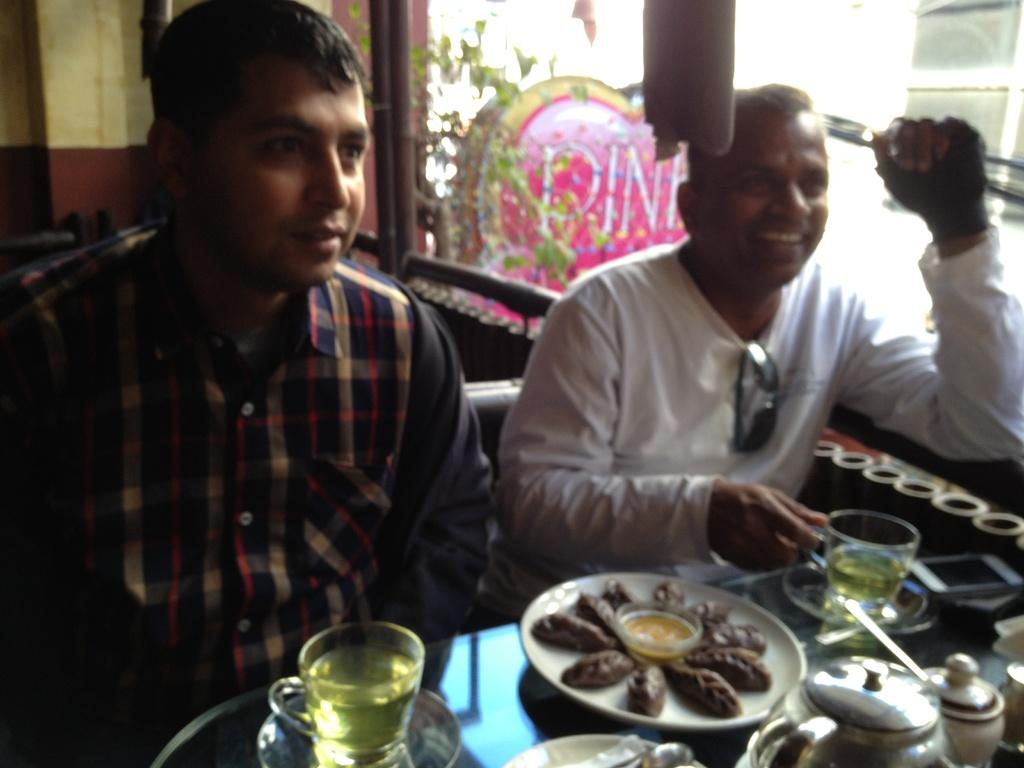How many people are in the image? There are two men in the image. What are the men doing in the image? The men are sitting in front of food. What type of beverage is present in the image? There is tea in the image. What is used to serve the tea? There are cups in the image. What is used to heat the tea? There are kettles in the image. What can be seen on the right side of the image? There is a glass wall on the right side of the image. What type of flag is hanging on the glass wall in the image? There is no flag present in the image; only a glass wall can be seen on the right side. What type of jewel is being used to stir the tea in the image? There are no jewels present in the image, and stirring the tea is not mentioned. 